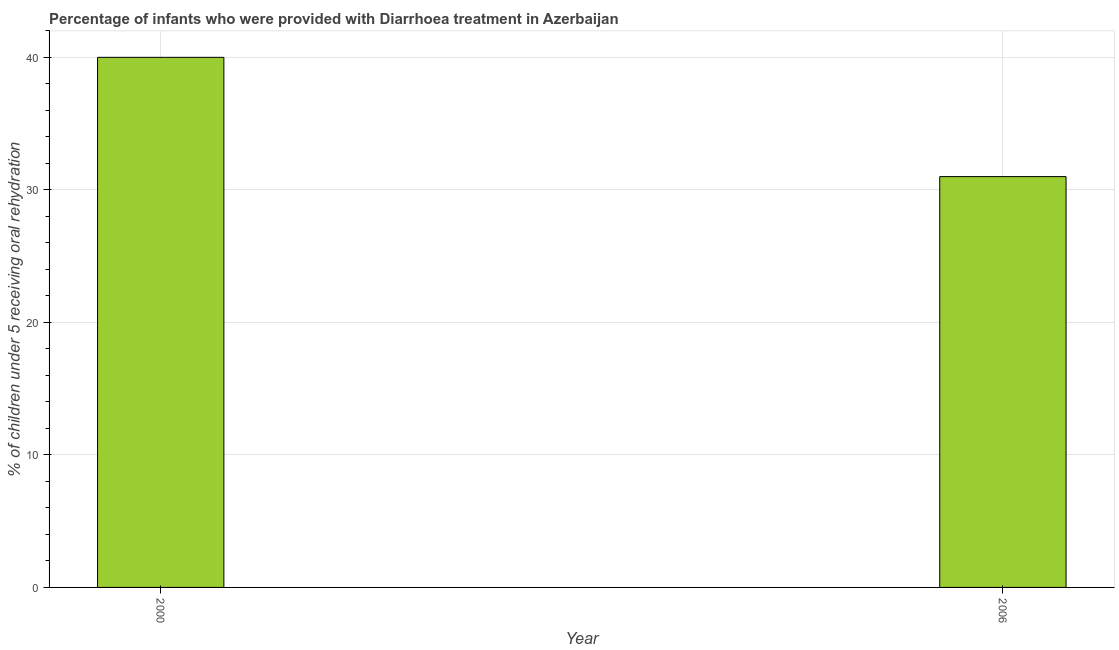Does the graph contain any zero values?
Keep it short and to the point. No. Does the graph contain grids?
Make the answer very short. Yes. What is the title of the graph?
Offer a terse response. Percentage of infants who were provided with Diarrhoea treatment in Azerbaijan. What is the label or title of the Y-axis?
Your answer should be compact. % of children under 5 receiving oral rehydration. What is the percentage of children who were provided with treatment diarrhoea in 2006?
Offer a very short reply. 31. Across all years, what is the minimum percentage of children who were provided with treatment diarrhoea?
Your response must be concise. 31. In which year was the percentage of children who were provided with treatment diarrhoea maximum?
Your answer should be very brief. 2000. In which year was the percentage of children who were provided with treatment diarrhoea minimum?
Keep it short and to the point. 2006. What is the difference between the percentage of children who were provided with treatment diarrhoea in 2000 and 2006?
Your answer should be compact. 9. What is the average percentage of children who were provided with treatment diarrhoea per year?
Ensure brevity in your answer.  35. What is the median percentage of children who were provided with treatment diarrhoea?
Provide a short and direct response. 35.5. Do a majority of the years between 2000 and 2006 (inclusive) have percentage of children who were provided with treatment diarrhoea greater than 18 %?
Your answer should be compact. Yes. What is the ratio of the percentage of children who were provided with treatment diarrhoea in 2000 to that in 2006?
Offer a very short reply. 1.29. In how many years, is the percentage of children who were provided with treatment diarrhoea greater than the average percentage of children who were provided with treatment diarrhoea taken over all years?
Your answer should be compact. 1. How many bars are there?
Your answer should be compact. 2. What is the difference between the % of children under 5 receiving oral rehydration in 2000 and 2006?
Offer a terse response. 9. What is the ratio of the % of children under 5 receiving oral rehydration in 2000 to that in 2006?
Your answer should be compact. 1.29. 